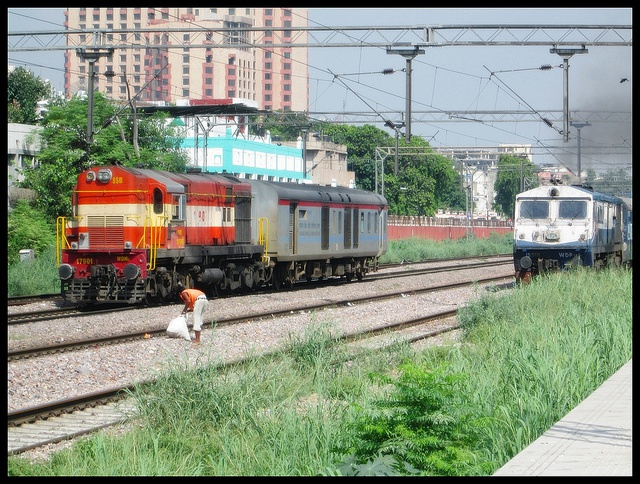Describe the objects in this image and their specific colors. I can see train in black, gray, darkgray, and brown tones, train in black, lightgray, gray, and darkgray tones, and people in black, lightgray, darkgray, tan, and maroon tones in this image. 